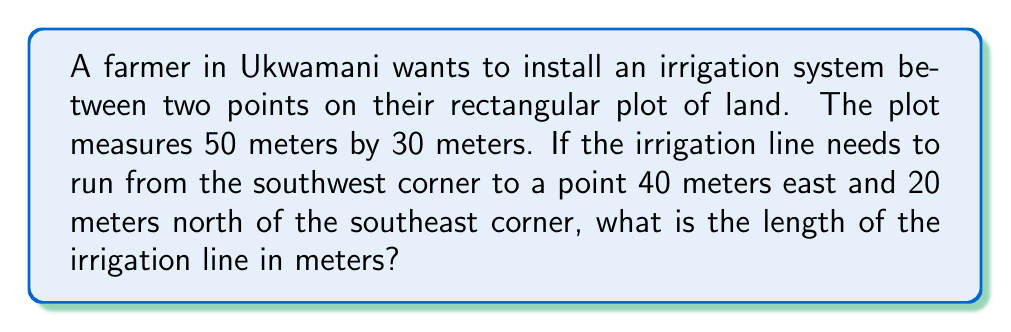Help me with this question. Let's approach this step-by-step using the distance formula:

1) First, we need to set up a coordinate system. Let's place the origin (0,0) at the southwest corner of the plot.

2) The two points we're concerned with are:
   Point A (southwest corner): (0, 0)
   Point B (40m east and 20m north of southeast corner): (40, 50)

3) We can visualize this as follows:

[asy]
unitsize(4mm);
draw((0,0)--(50,0)--(50,30)--(0,30)--cycle);
dot((0,0));
dot((40,50));
draw((0,0)--(40,50), dashed);
label("A (0,0)", (0,0), SW);
label("B (40,50)", (40,50), NE);
label("50m", (25,0), S);
label("30m", (50,15), E);
[/asy]

4) Now we can use the distance formula:
   $$d = \sqrt{(x_2-x_1)^2 + (y_2-y_1)^2}$$

5) Plugging in our coordinates:
   $$d = \sqrt{(40-0)^2 + (50-0)^2}$$

6) Simplify:
   $$d = \sqrt{40^2 + 50^2}$$
   $$d = \sqrt{1600 + 2500}$$
   $$d = \sqrt{4100}$$

7) Calculate the square root:
   $$d \approx 64.03 \text{ meters}$$

Thus, the irrigation line will need to be approximately 64.03 meters long.
Answer: $64.03 \text{ meters}$ 